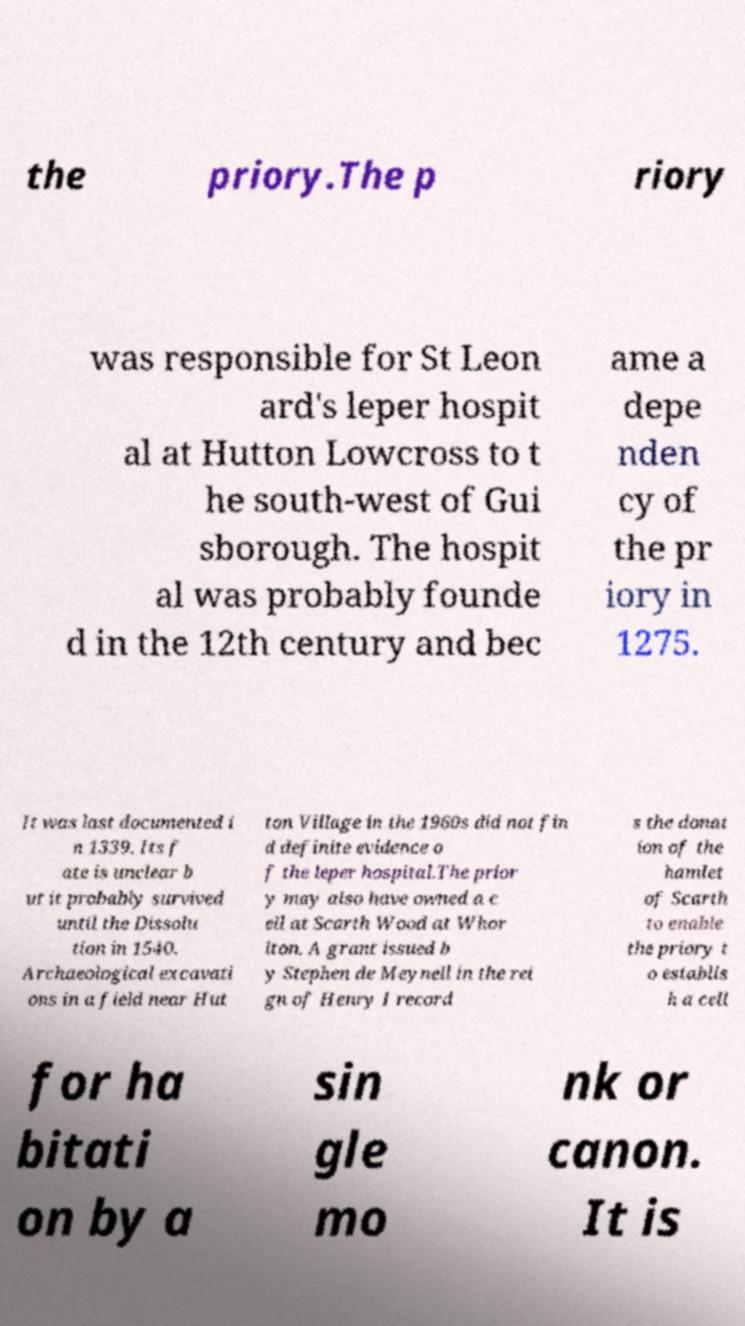For documentation purposes, I need the text within this image transcribed. Could you provide that? the priory.The p riory was responsible for St Leon ard's leper hospit al at Hutton Lowcross to t he south-west of Gui sborough. The hospit al was probably founde d in the 12th century and bec ame a depe nden cy of the pr iory in 1275. It was last documented i n 1339. Its f ate is unclear b ut it probably survived until the Dissolu tion in 1540. Archaeological excavati ons in a field near Hut ton Village in the 1960s did not fin d definite evidence o f the leper hospital.The prior y may also have owned a c ell at Scarth Wood at Whor lton. A grant issued b y Stephen de Meynell in the rei gn of Henry I record s the donat ion of the hamlet of Scarth to enable the priory t o establis h a cell for ha bitati on by a sin gle mo nk or canon. It is 